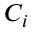Convert formula to latex. <formula><loc_0><loc_0><loc_500><loc_500>C _ { i }</formula> 